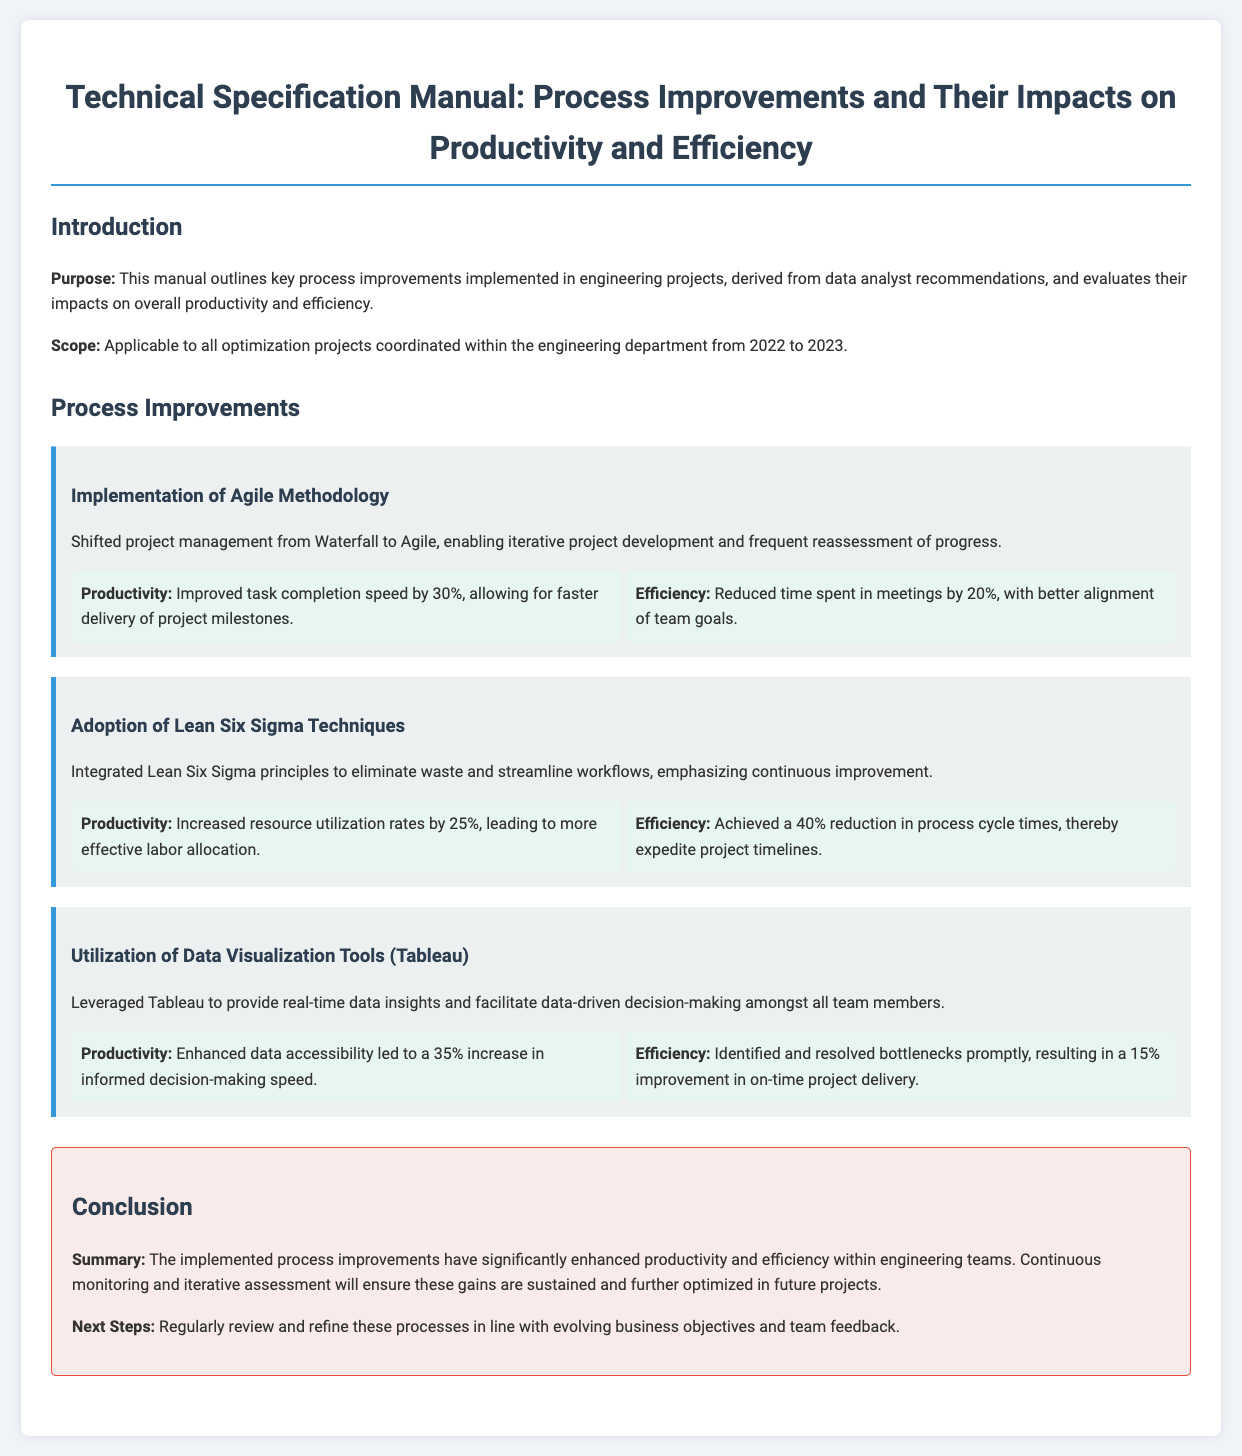what is the title of the manual? The title is presented in the first section of the document.
Answer: Technical Specification Manual: Process Improvements and Their Impacts on Productivity and Efficiency what methodology was implemented in project management? The methodology change is highlighted under the Process Improvements section.
Answer: Agile Methodology by what percentage did task completion speed improve? This statistic is detailed in the section regarding the Agile Methodology implementation.
Answer: 30% which techniques were adopted to eliminate waste? This information is found in the relevant improvement section discussing process integration.
Answer: Lean Six Sigma Techniques what was the reduction in process cycle times? The reduction statistic is provided under the Lean Six Sigma Techniques improvement.
Answer: 40% how was data accessibility enhanced? This enhancement is noted in the section discussing the use of specific tools.
Answer: Utilization of Data Visualization Tools (Tableau) what is the summary of the implemented process improvements? The summary is provided in the conclusion section of the document.
Answer: Significantly enhanced productivity and efficiency within engineering teams what is the next step mentioned in the manual? The next step is indicated in the conclusion section regarding future actions.
Answer: Regularly review and refine these processes 